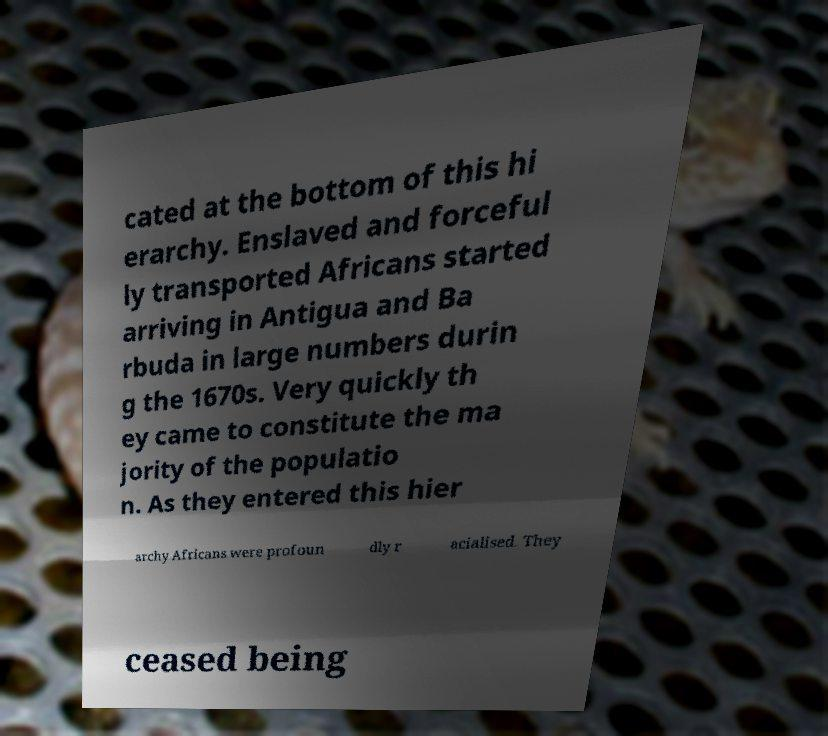I need the written content from this picture converted into text. Can you do that? cated at the bottom of this hi erarchy. Enslaved and forceful ly transported Africans started arriving in Antigua and Ba rbuda in large numbers durin g the 1670s. Very quickly th ey came to constitute the ma jority of the populatio n. As they entered this hier archy Africans were profoun dly r acialised. They ceased being 